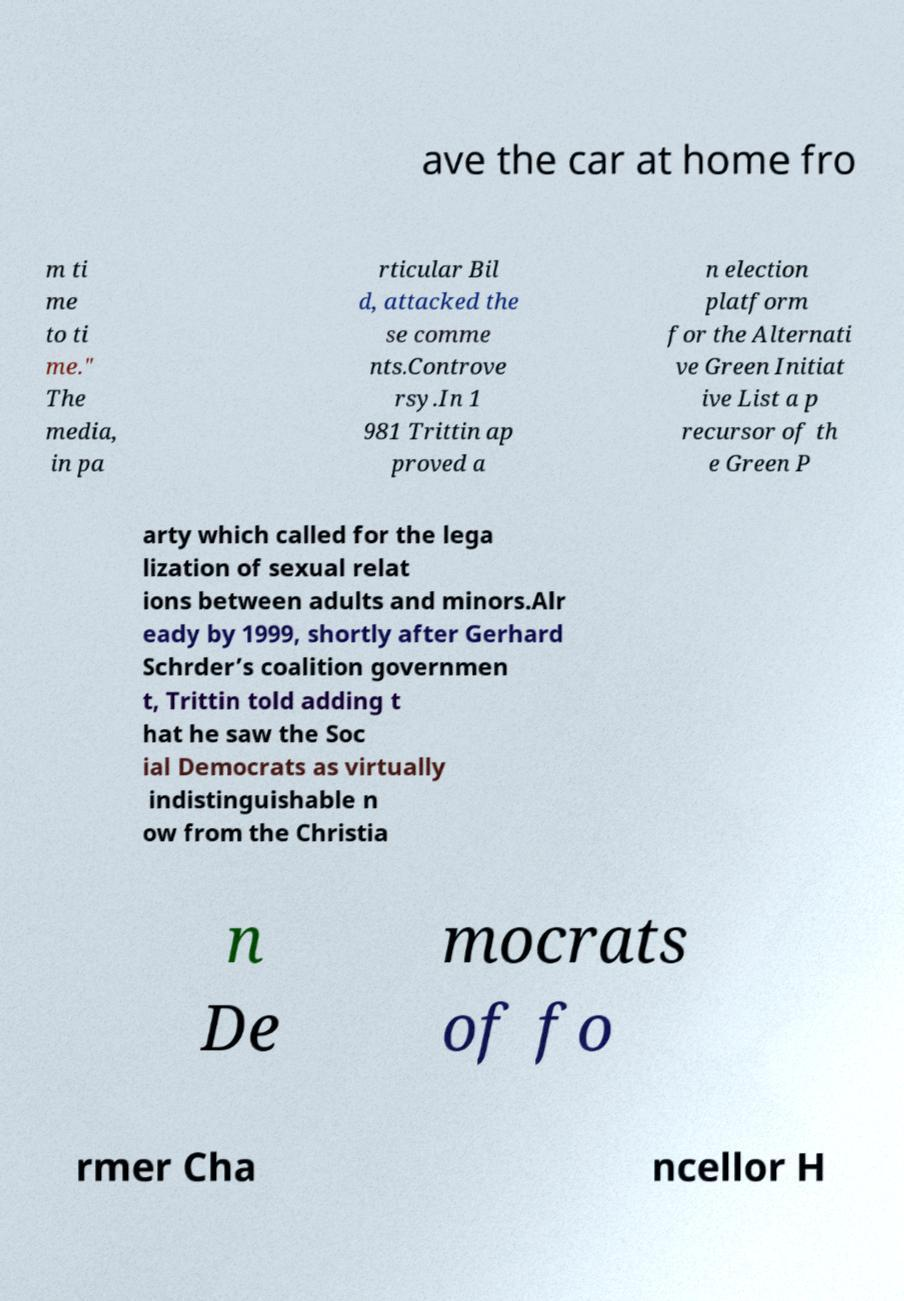What messages or text are displayed in this image? I need them in a readable, typed format. ave the car at home fro m ti me to ti me." The media, in pa rticular Bil d, attacked the se comme nts.Controve rsy.In 1 981 Trittin ap proved a n election platform for the Alternati ve Green Initiat ive List a p recursor of th e Green P arty which called for the lega lization of sexual relat ions between adults and minors.Alr eady by 1999, shortly after Gerhard Schrder’s coalition governmen t, Trittin told adding t hat he saw the Soc ial Democrats as virtually indistinguishable n ow from the Christia n De mocrats of fo rmer Cha ncellor H 